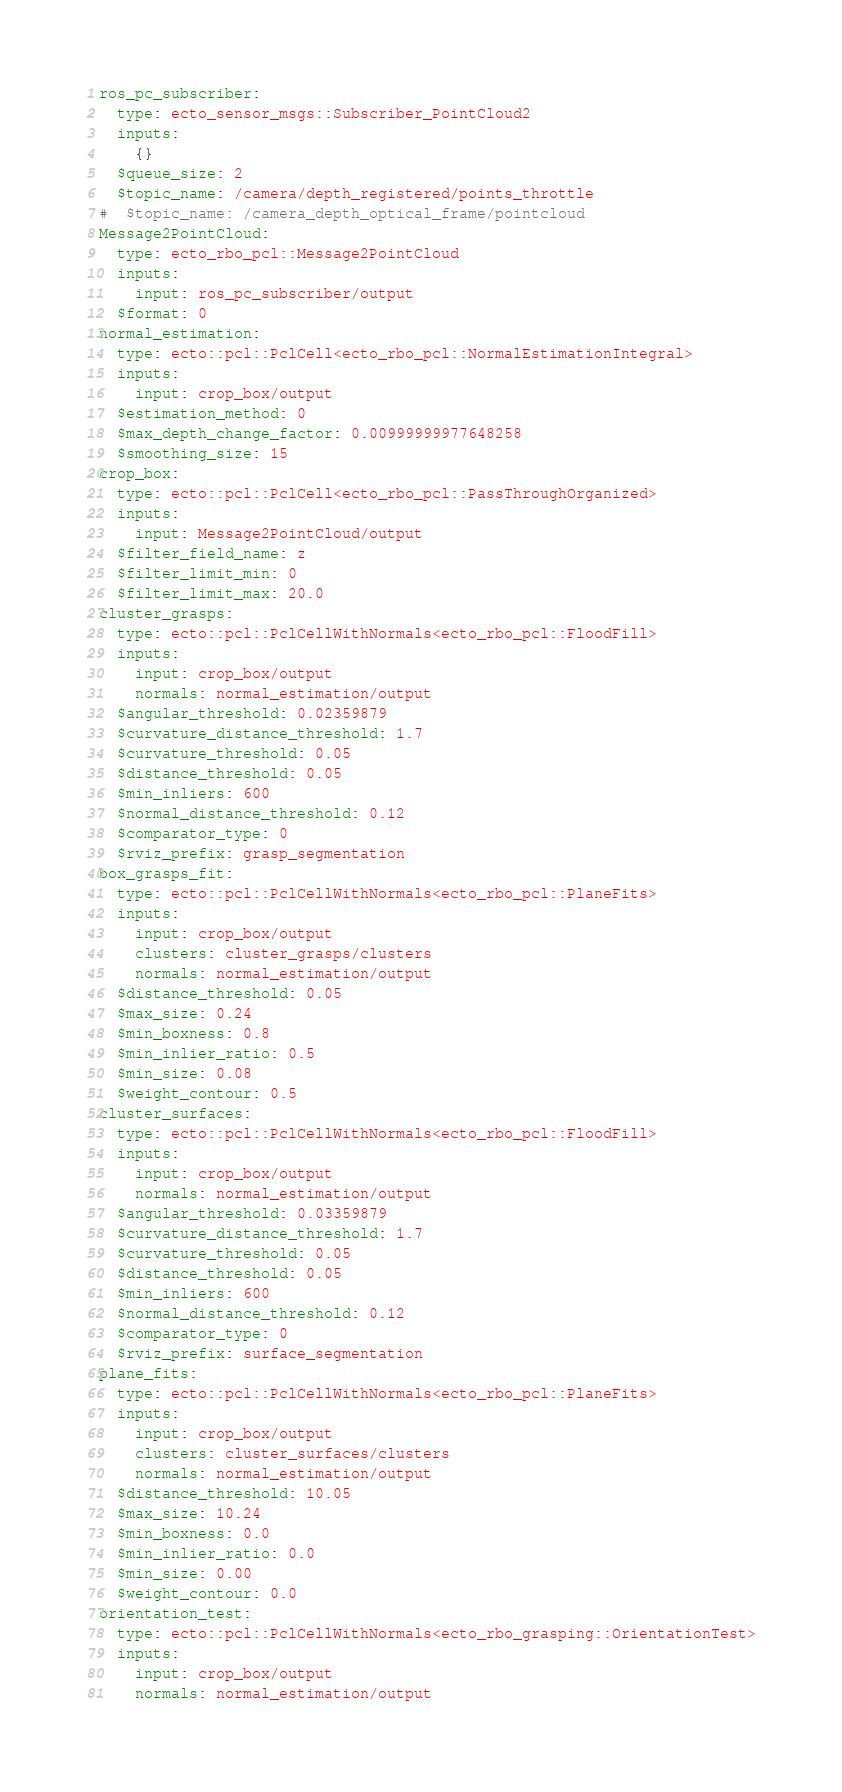Convert code to text. <code><loc_0><loc_0><loc_500><loc_500><_YAML_>ros_pc_subscriber:
  type: ecto_sensor_msgs::Subscriber_PointCloud2
  inputs:
    {}
  $queue_size: 2
  $topic_name: /camera/depth_registered/points_throttle
#  $topic_name: /camera_depth_optical_frame/pointcloud
Message2PointCloud:
  type: ecto_rbo_pcl::Message2PointCloud
  inputs:
    input: ros_pc_subscriber/output
  $format: 0
normal_estimation:
  type: ecto::pcl::PclCell<ecto_rbo_pcl::NormalEstimationIntegral>
  inputs:
    input: crop_box/output
  $estimation_method: 0
  $max_depth_change_factor: 0.00999999977648258
  $smoothing_size: 15
crop_box:
  type: ecto::pcl::PclCell<ecto_rbo_pcl::PassThroughOrganized>
  inputs:
    input: Message2PointCloud/output
  $filter_field_name: z
  $filter_limit_min: 0
  $filter_limit_max: 20.0
cluster_grasps:
  type: ecto::pcl::PclCellWithNormals<ecto_rbo_pcl::FloodFill>
  inputs:
    input: crop_box/output
    normals: normal_estimation/output
  $angular_threshold: 0.02359879
  $curvature_distance_threshold: 1.7
  $curvature_threshold: 0.05
  $distance_threshold: 0.05
  $min_inliers: 600
  $normal_distance_threshold: 0.12
  $comparator_type: 0
  $rviz_prefix: grasp_segmentation
box_grasps_fit:
  type: ecto::pcl::PclCellWithNormals<ecto_rbo_pcl::PlaneFits>
  inputs:
    input: crop_box/output
    clusters: cluster_grasps/clusters
    normals: normal_estimation/output
  $distance_threshold: 0.05
  $max_size: 0.24
  $min_boxness: 0.8
  $min_inlier_ratio: 0.5
  $min_size: 0.08
  $weight_contour: 0.5
cluster_surfaces:
  type: ecto::pcl::PclCellWithNormals<ecto_rbo_pcl::FloodFill>
  inputs:
    input: crop_box/output
    normals: normal_estimation/output
  $angular_threshold: 0.03359879
  $curvature_distance_threshold: 1.7
  $curvature_threshold: 0.05
  $distance_threshold: 0.05
  $min_inliers: 600
  $normal_distance_threshold: 0.12
  $comparator_type: 0
  $rviz_prefix: surface_segmentation
plane_fits:
  type: ecto::pcl::PclCellWithNormals<ecto_rbo_pcl::PlaneFits>
  inputs:
    input: crop_box/output
    clusters: cluster_surfaces/clusters
    normals: normal_estimation/output
  $distance_threshold: 10.05
  $max_size: 10.24
  $min_boxness: 0.0
  $min_inlier_ratio: 0.0
  $min_size: 0.00
  $weight_contour: 0.0
orientation_test:
  type: ecto::pcl::PclCellWithNormals<ecto_rbo_grasping::OrientationTest>
  inputs:
    input: crop_box/output
    normals: normal_estimation/output
</code> 